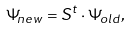Convert formula to latex. <formula><loc_0><loc_0><loc_500><loc_500>\Psi _ { n e w } = S ^ { t } \cdot \Psi _ { o l d } ,</formula> 